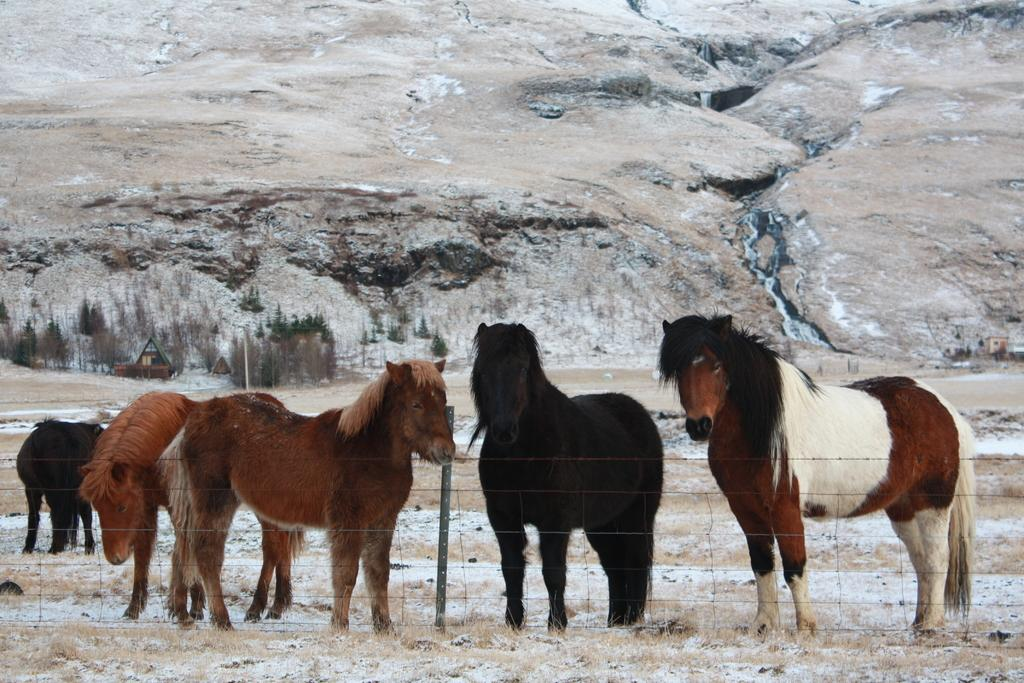What animals can be seen in the image? There are horses of different colors in the image. What is the ground covered with in the image? There is snow and grass visible in the image. What type of vegetation is present in the image? There are trees in the image. What type of landscape feature is visible in the image? There is a mountain in the image. What structures are present in the image? There is a fence and a pole in the image. What type of rice can be seen growing in the image? There is no rice present in the image; it features horses in a snowy landscape with trees, a mountain, a fence, and a pole. 